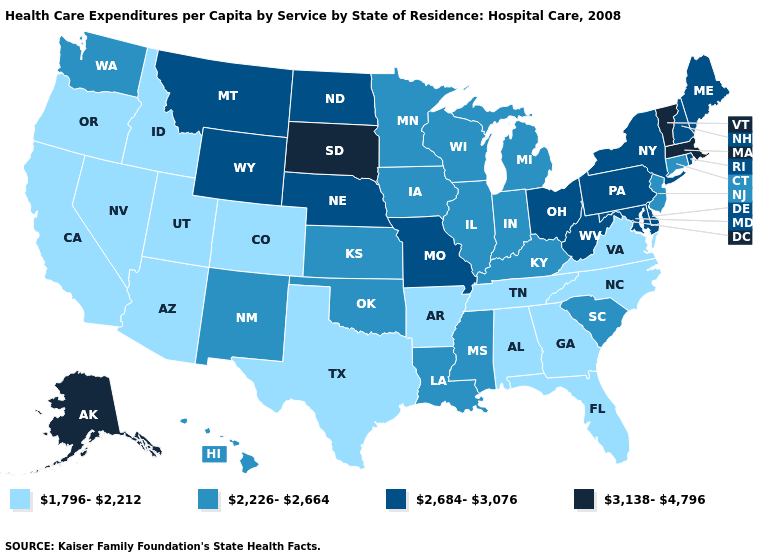What is the value of Nebraska?
Quick response, please. 2,684-3,076. What is the value of Colorado?
Answer briefly. 1,796-2,212. What is the value of North Carolina?
Keep it brief. 1,796-2,212. What is the highest value in states that border Virginia?
Write a very short answer. 2,684-3,076. What is the lowest value in the USA?
Write a very short answer. 1,796-2,212. What is the lowest value in states that border Indiana?
Keep it brief. 2,226-2,664. Name the states that have a value in the range 2,226-2,664?
Give a very brief answer. Connecticut, Hawaii, Illinois, Indiana, Iowa, Kansas, Kentucky, Louisiana, Michigan, Minnesota, Mississippi, New Jersey, New Mexico, Oklahoma, South Carolina, Washington, Wisconsin. Does the map have missing data?
Answer briefly. No. Among the states that border Indiana , which have the highest value?
Write a very short answer. Ohio. Name the states that have a value in the range 2,684-3,076?
Answer briefly. Delaware, Maine, Maryland, Missouri, Montana, Nebraska, New Hampshire, New York, North Dakota, Ohio, Pennsylvania, Rhode Island, West Virginia, Wyoming. Does Alabama have the highest value in the South?
Answer briefly. No. What is the lowest value in the USA?
Give a very brief answer. 1,796-2,212. Which states have the lowest value in the MidWest?
Write a very short answer. Illinois, Indiana, Iowa, Kansas, Michigan, Minnesota, Wisconsin. What is the value of Florida?
Be succinct. 1,796-2,212. What is the highest value in states that border Louisiana?
Quick response, please. 2,226-2,664. 